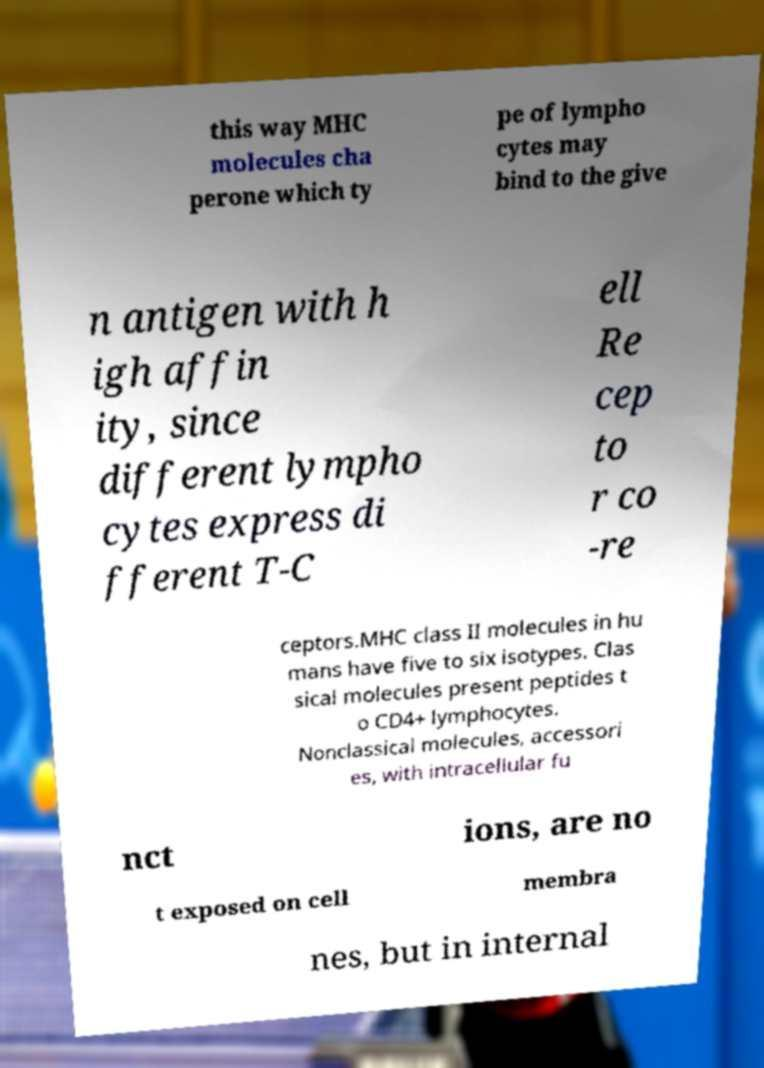There's text embedded in this image that I need extracted. Can you transcribe it verbatim? this way MHC molecules cha perone which ty pe of lympho cytes may bind to the give n antigen with h igh affin ity, since different lympho cytes express di fferent T-C ell Re cep to r co -re ceptors.MHC class II molecules in hu mans have five to six isotypes. Clas sical molecules present peptides t o CD4+ lymphocytes. Nonclassical molecules, accessori es, with intracellular fu nct ions, are no t exposed on cell membra nes, but in internal 